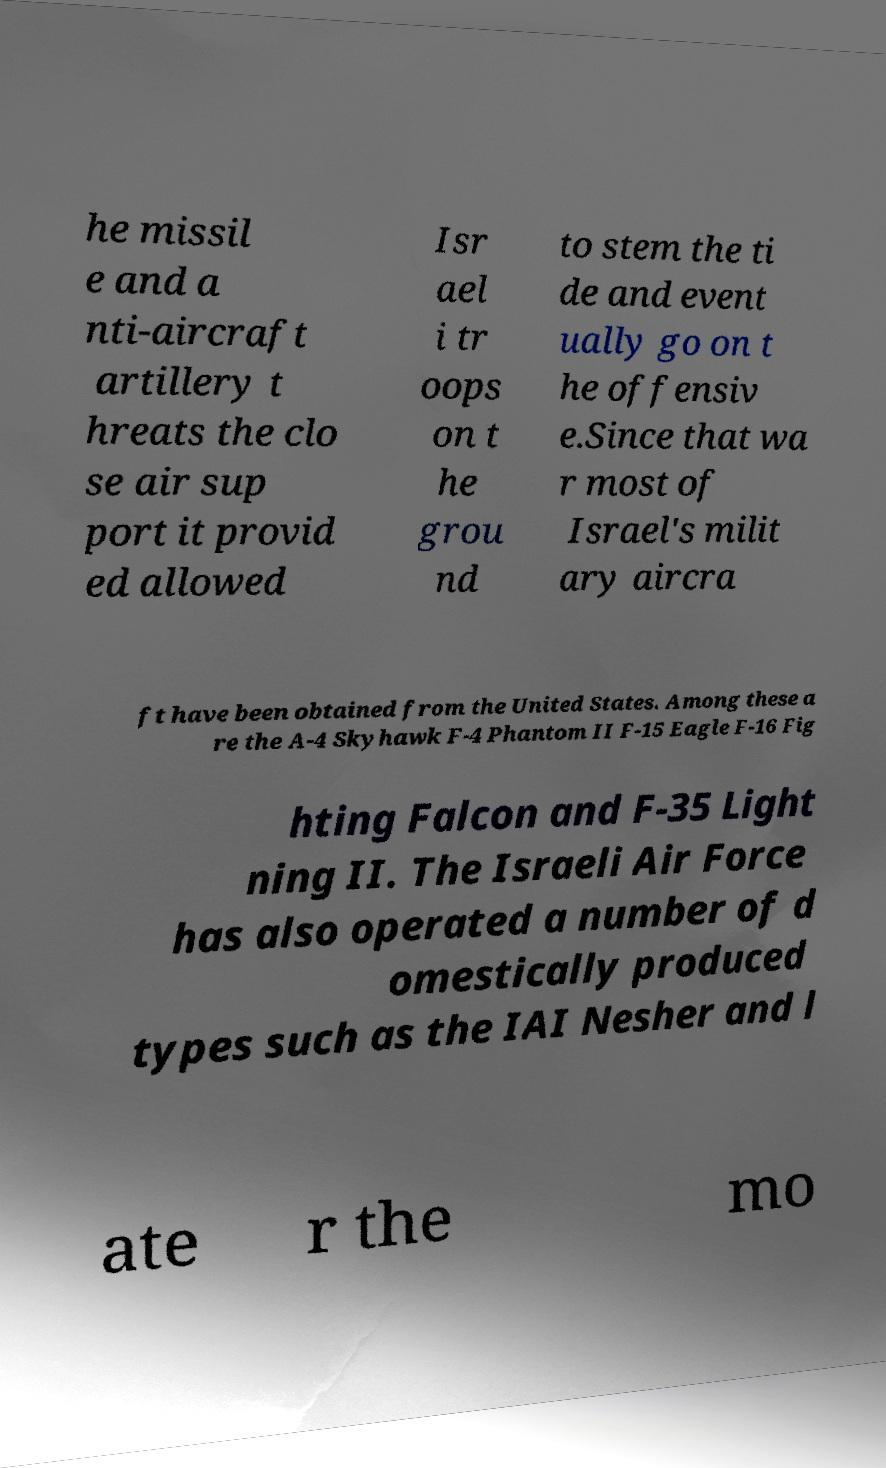What messages or text are displayed in this image? I need them in a readable, typed format. he missil e and a nti-aircraft artillery t hreats the clo se air sup port it provid ed allowed Isr ael i tr oops on t he grou nd to stem the ti de and event ually go on t he offensiv e.Since that wa r most of Israel's milit ary aircra ft have been obtained from the United States. Among these a re the A-4 Skyhawk F-4 Phantom II F-15 Eagle F-16 Fig hting Falcon and F-35 Light ning II. The Israeli Air Force has also operated a number of d omestically produced types such as the IAI Nesher and l ate r the mo 